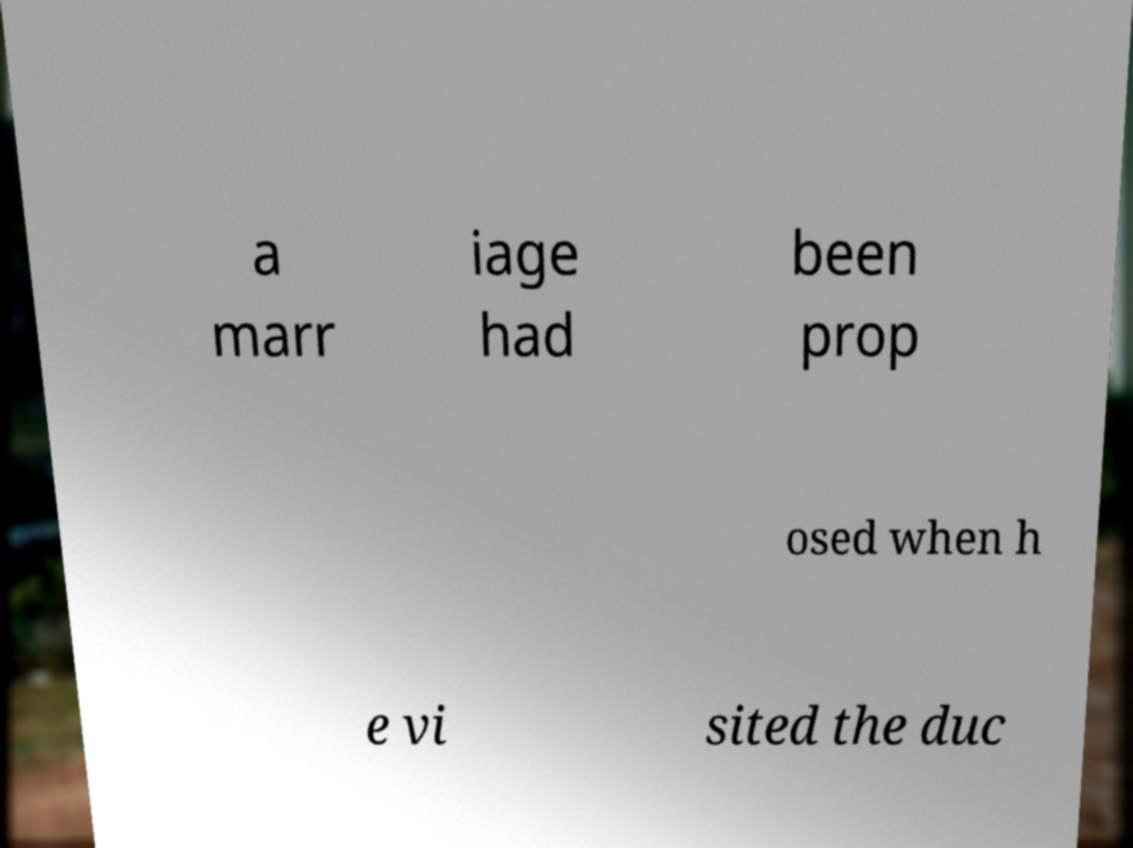I need the written content from this picture converted into text. Can you do that? a marr iage had been prop osed when h e vi sited the duc 